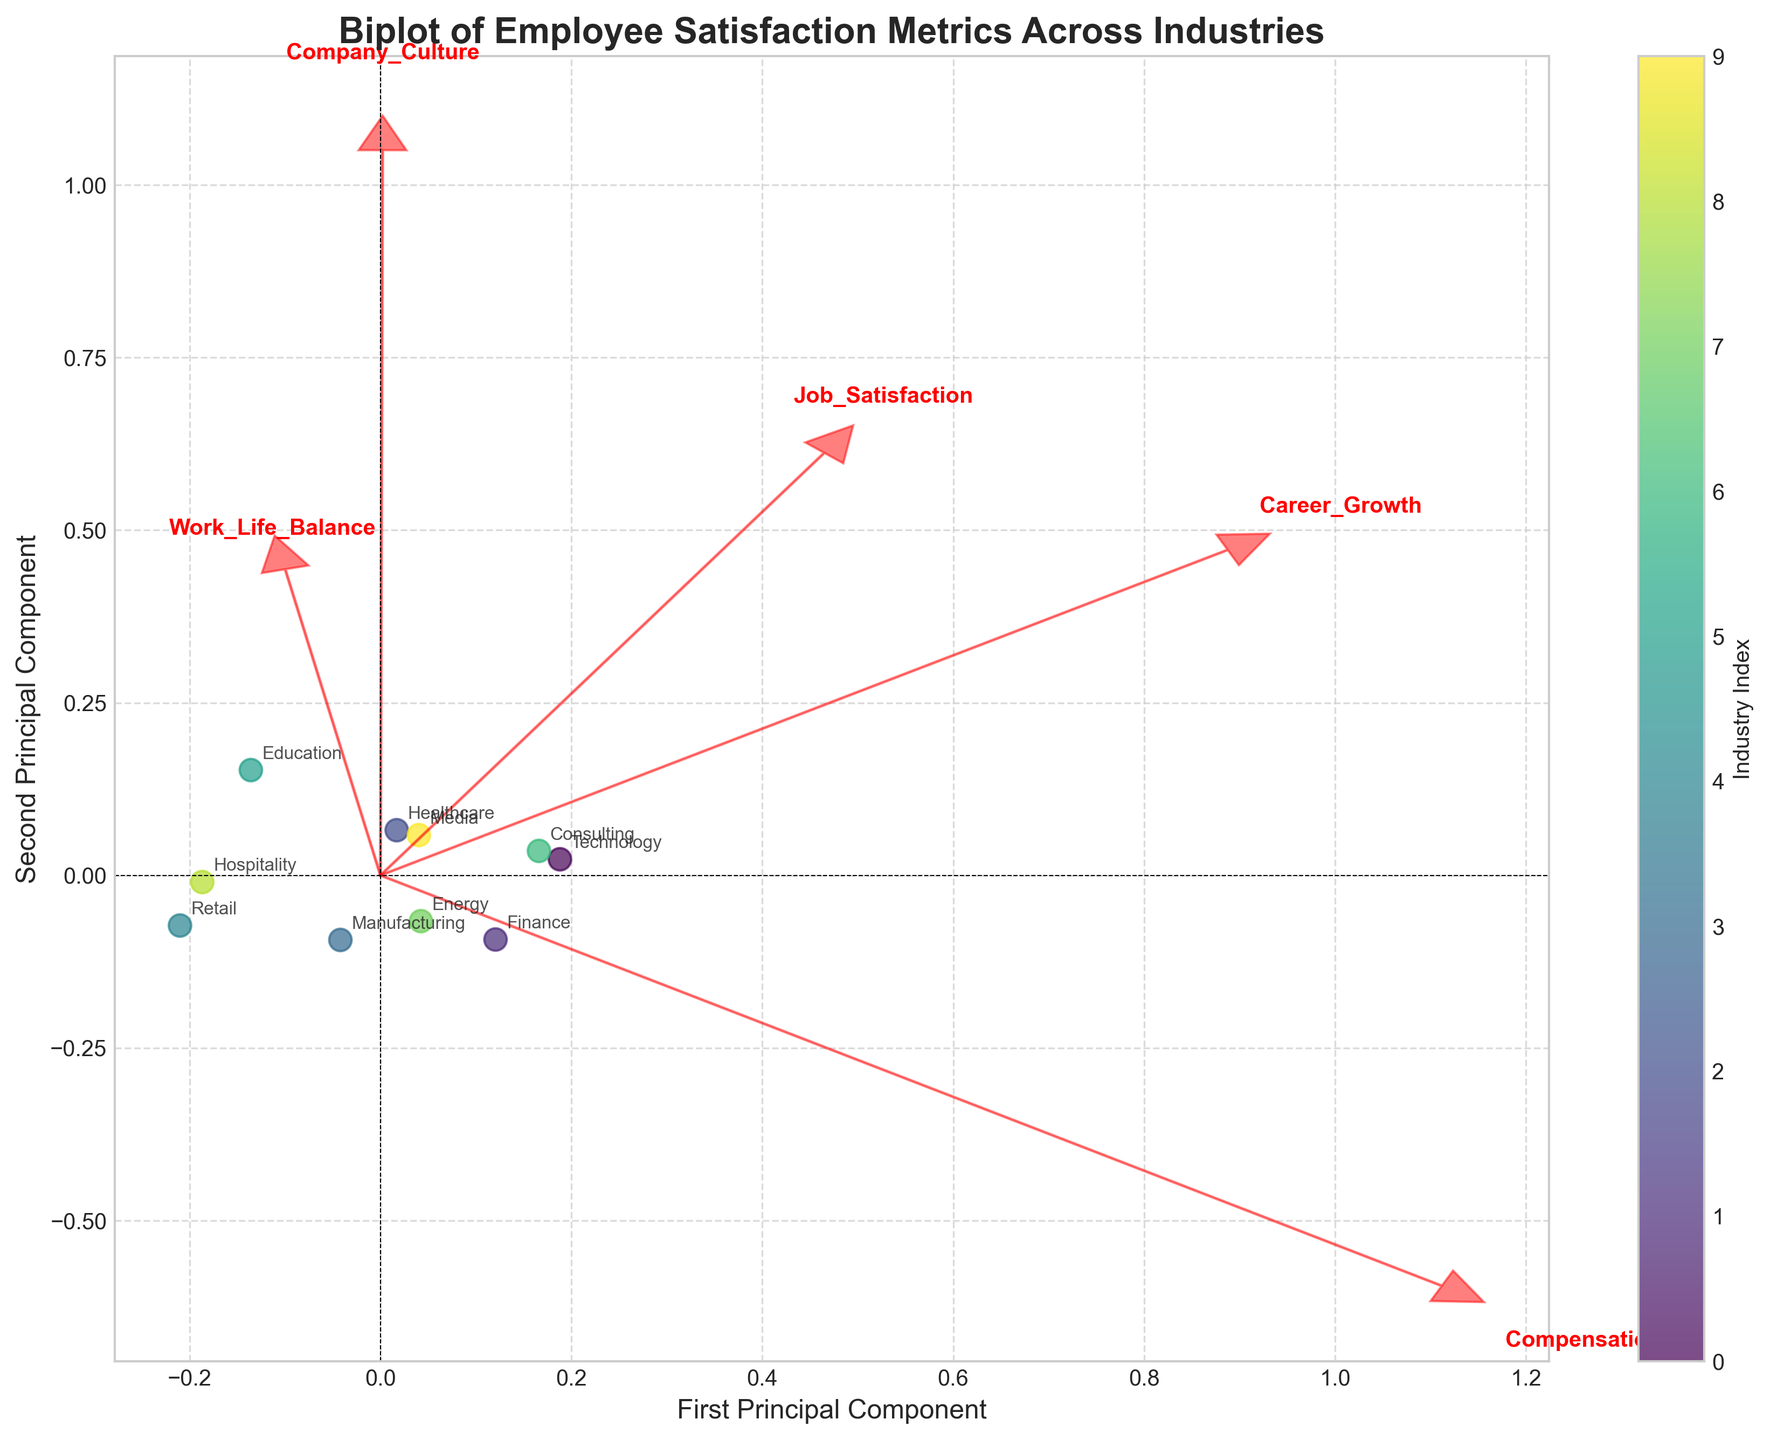What's the title of the plot? The title is located at the top of the plot, displayed in a prominent font size and style.
Answer: Biplot of Employee Satisfaction Metrics Across Industries How many industries are represented in the plot? The industries are labeled next to each data point in the scatter plot. Count the different labels to find the total number.
Answer: 10 Which industry has the highest first principal component score? The first principal component is represented by the x-axis. The industry farthest to the right on the x-axis has the highest score.
Answer: Technology What is the general direction of the 'Compensation' feature vector? The feature vectors are represented by red arrows. Observe the arrow labeled 'Compensation' to determine its direction.
Answer: Positive x and y directions Which two industries are located closest to each other? Look at the distances between the data points in the scatter plot. The two points that are nearest to each other represent the closest industries.
Answer: Finance and Energy Which feature contributes the most to the second principal component? The second principal component is represented by the y-axis. The feature vector with the longest projection along the y-axis contributes the most.
Answer: Work_Life_Balance Is 'Work_Life_Balance' more aligned with the first or second principal component? Compare the direction of the 'Work_Life_Balance' vector to both principal axes. Determine which axis it aligns more closely with.
Answer: Second principal component Which industries are located in the negative region of both principal components? Look at the data points in the scatter plot situated in the quadrant where both x and y values are negative. Identify the industries labeled there.
Answer: Retail Does 'Career_Growth' have a stronger relationship with the first or second principal component? Compare the angle and projection of the 'Career_Growth' feature vector with respect to both principal component axes.
Answer: First principal component Are 'Job_Satisfaction' and 'Company_Culture' vectors pointing in similar directions? Evaluate the orientation and angle of the vectors representing 'Job_Satisfaction' and 'Company_Culture' to see if they are parallel or diverging.
Answer: Yes 